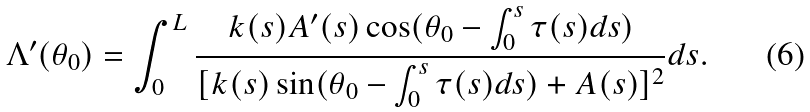<formula> <loc_0><loc_0><loc_500><loc_500>\Lambda ^ { \prime } ( \theta _ { 0 } ) = \int _ { 0 } ^ { L } \frac { k ( s ) A ^ { \prime } ( s ) \cos ( \theta _ { 0 } - \int _ { 0 } ^ { s } \tau ( s ) d s ) } { [ k ( s ) \sin ( \theta _ { 0 } - \int _ { 0 } ^ { s } \tau ( s ) d s ) + A ( s ) ] ^ { 2 } } d s .</formula> 